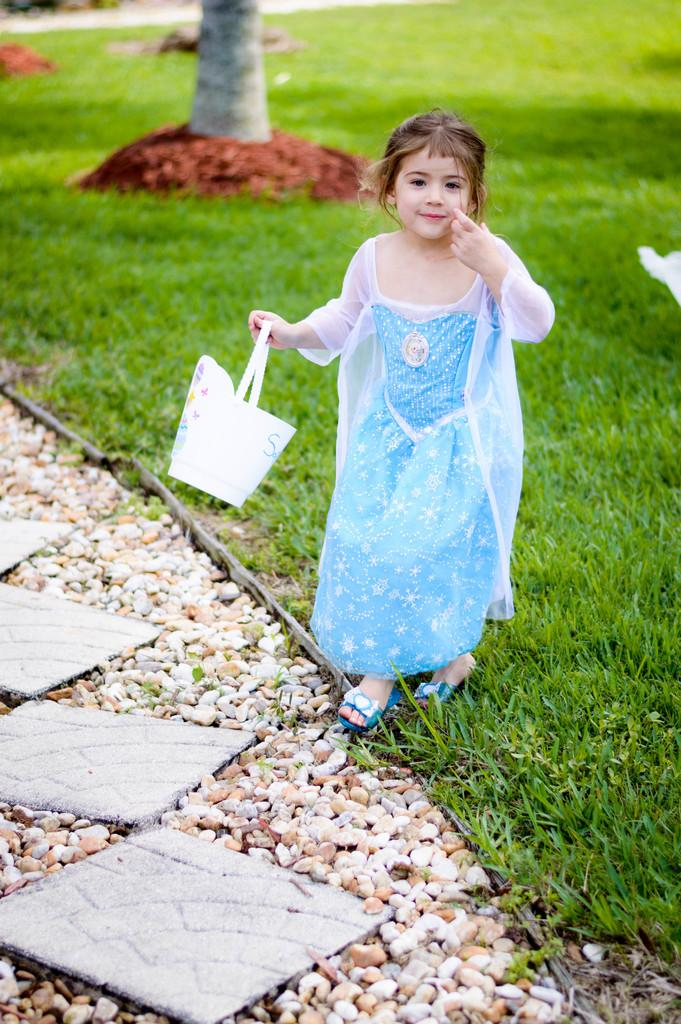Who is the main subject in the image? There is a girl in the image. What is the girl wearing? The girl is wearing a blue dress. What is the girl holding in the image? The girl is holding a bag. What type of terrain is visible at the bottom of the image? There are stones and green grass visible at the bottom of the image. What can be seen in the background of the image? There is a tree in the background of the image. How many cows are grazing in the background of the image? There are no cows present in the image; it features a girl, a blue dress, a bag, stones, green grass, and a tree in the background. What type of cats can be seen playing with the girl in the image? There are no cats present in the image; it features a girl, a blue dress, a bag, stones, green grass, and a tree in the background. 